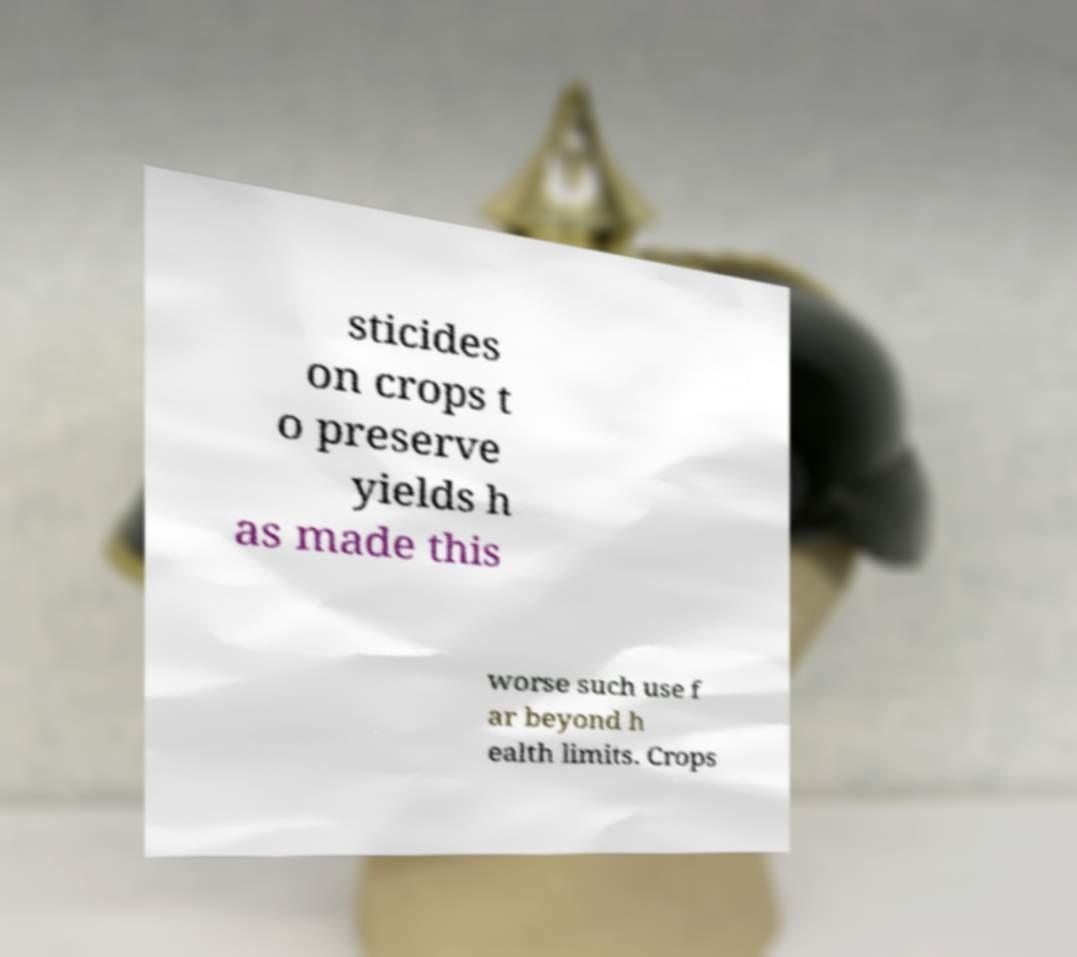What messages or text are displayed in this image? I need them in a readable, typed format. sticides on crops t o preserve yields h as made this worse such use f ar beyond h ealth limits. Crops 